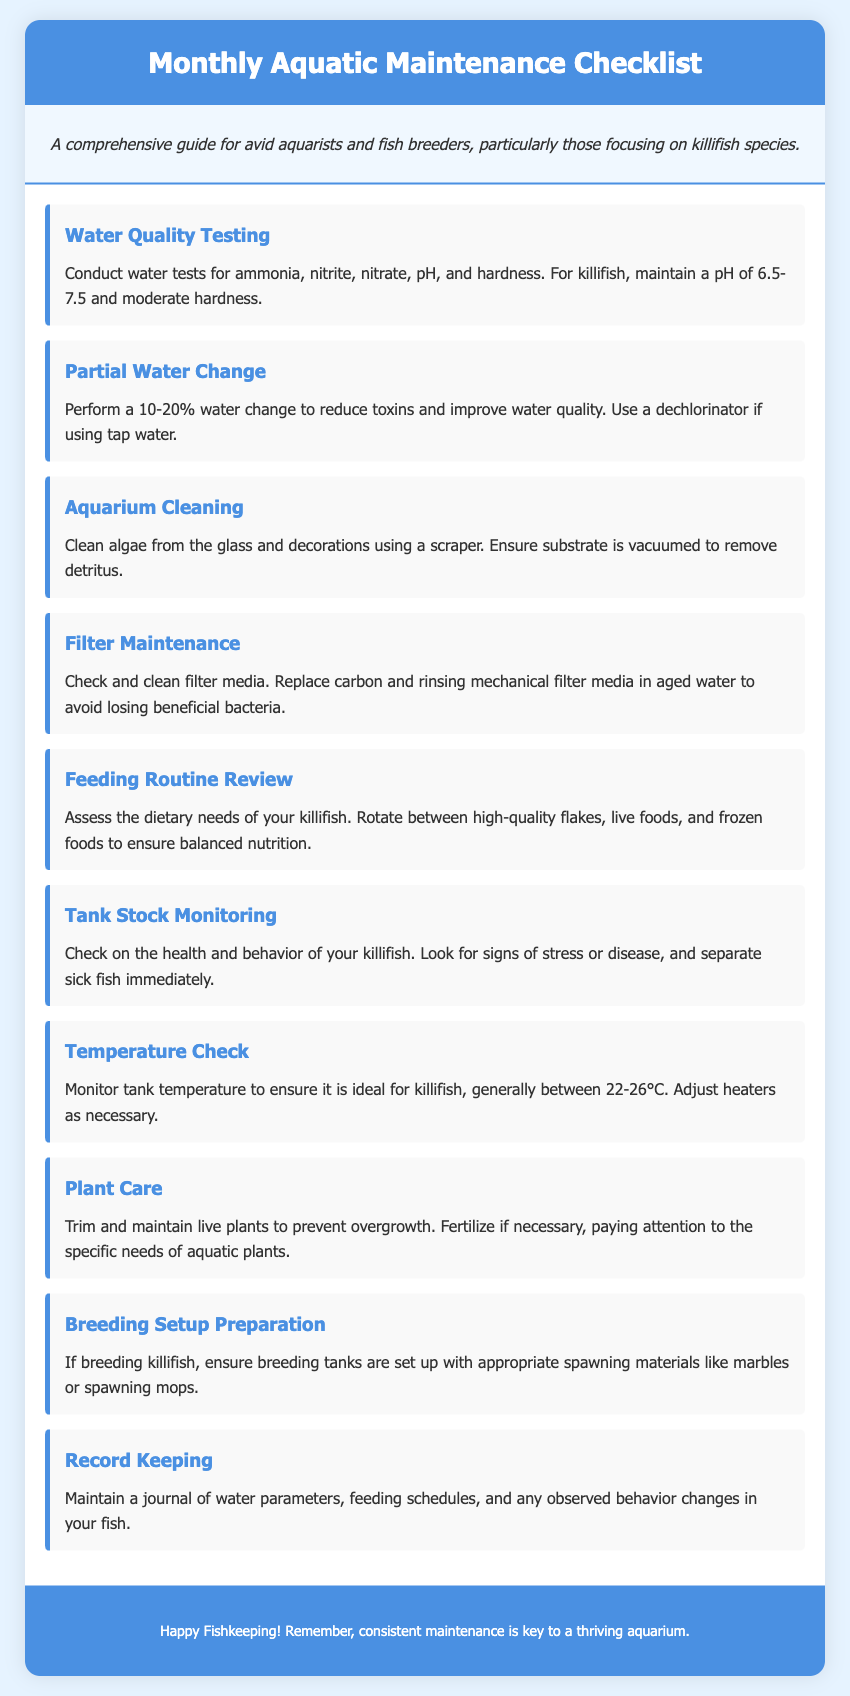What is the first task in the checklist? The first task listed in the checklist is "Water Quality Testing."
Answer: Water Quality Testing What pH range is recommended for killifish? The recommended pH range for killifish is between 6.5 and 7.5.
Answer: 6.5-7.5 How often should a partial water change be performed? The checklist suggests performing a 10-20% water change regularly.
Answer: 10-20% What should be checked and cleaned as part of filter maintenance? Filter maintenance includes checking and cleaning filter media.
Answer: Filter media What temperature range is ideal for killifish? The ideal temperature range for killifish is generally between 22-26°C.
Answer: 22-26°C What should be done if sick fish are found during monitoring? Sick fish should be separated immediately.
Answer: Separate sick fish What types of food should be included in the feeding routine for killifish? The feeding routine should rotate between high-quality flakes, live foods, and frozen foods.
Answer: Flakes, live foods, frozen foods What materials should be prepared for breeding killifish? Appropriate spawning materials like marbles or spawning mops should be set up for breeding.
Answer: Marbles, spawning mops What should be maintained as a record for your aquarium? A journal of water parameters, feeding schedules, and behavior changes should be maintained.
Answer: Journal of water parameters, feeding schedules, and behavior changes 